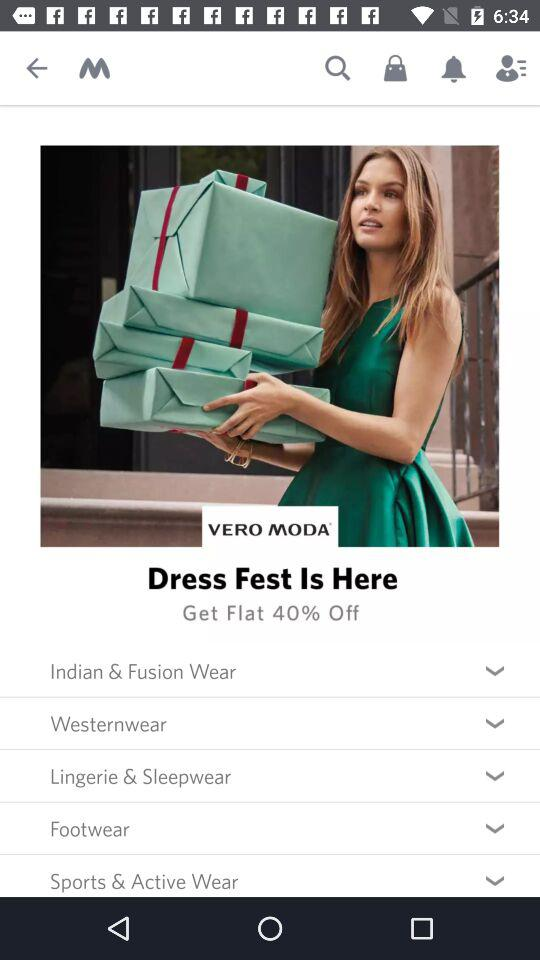What is the application name? The application name is "Myntra". 